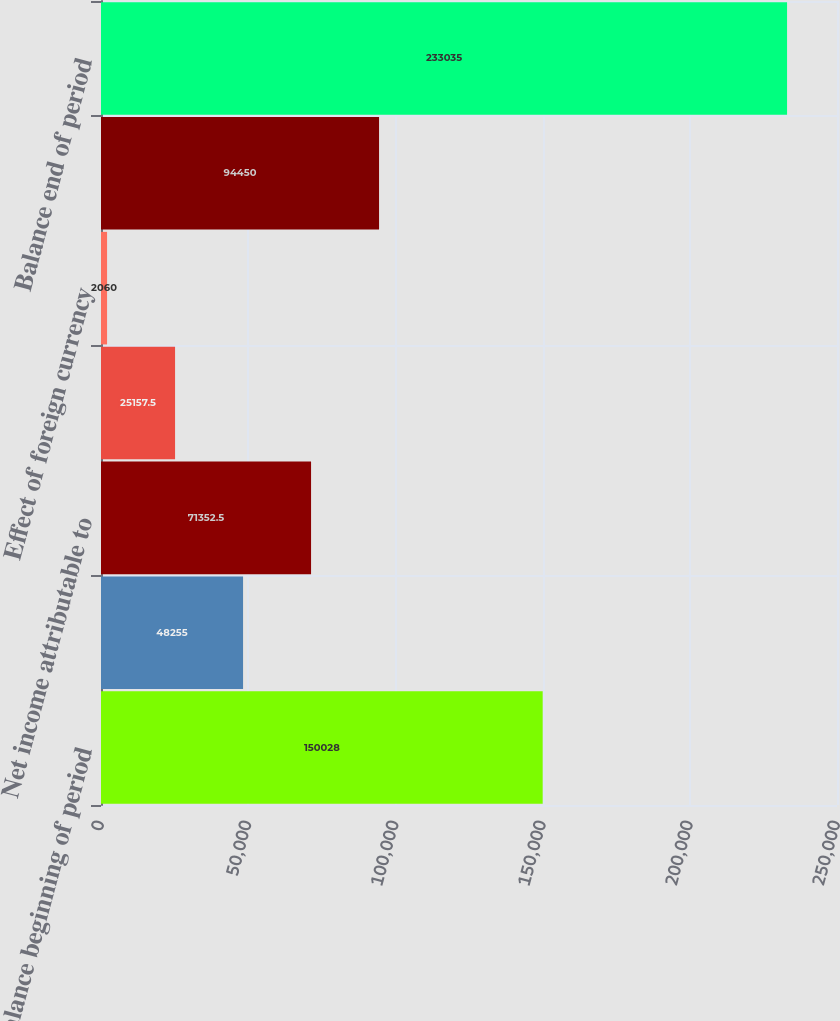Convert chart. <chart><loc_0><loc_0><loc_500><loc_500><bar_chart><fcel>Balance beginning of period<fcel>Net increase (decrease) in<fcel>Net income attributable to<fcel>Dividends declared<fcel>Effect of foreign currency<fcel>Change in fair value of<fcel>Balance end of period<nl><fcel>150028<fcel>48255<fcel>71352.5<fcel>25157.5<fcel>2060<fcel>94450<fcel>233035<nl></chart> 